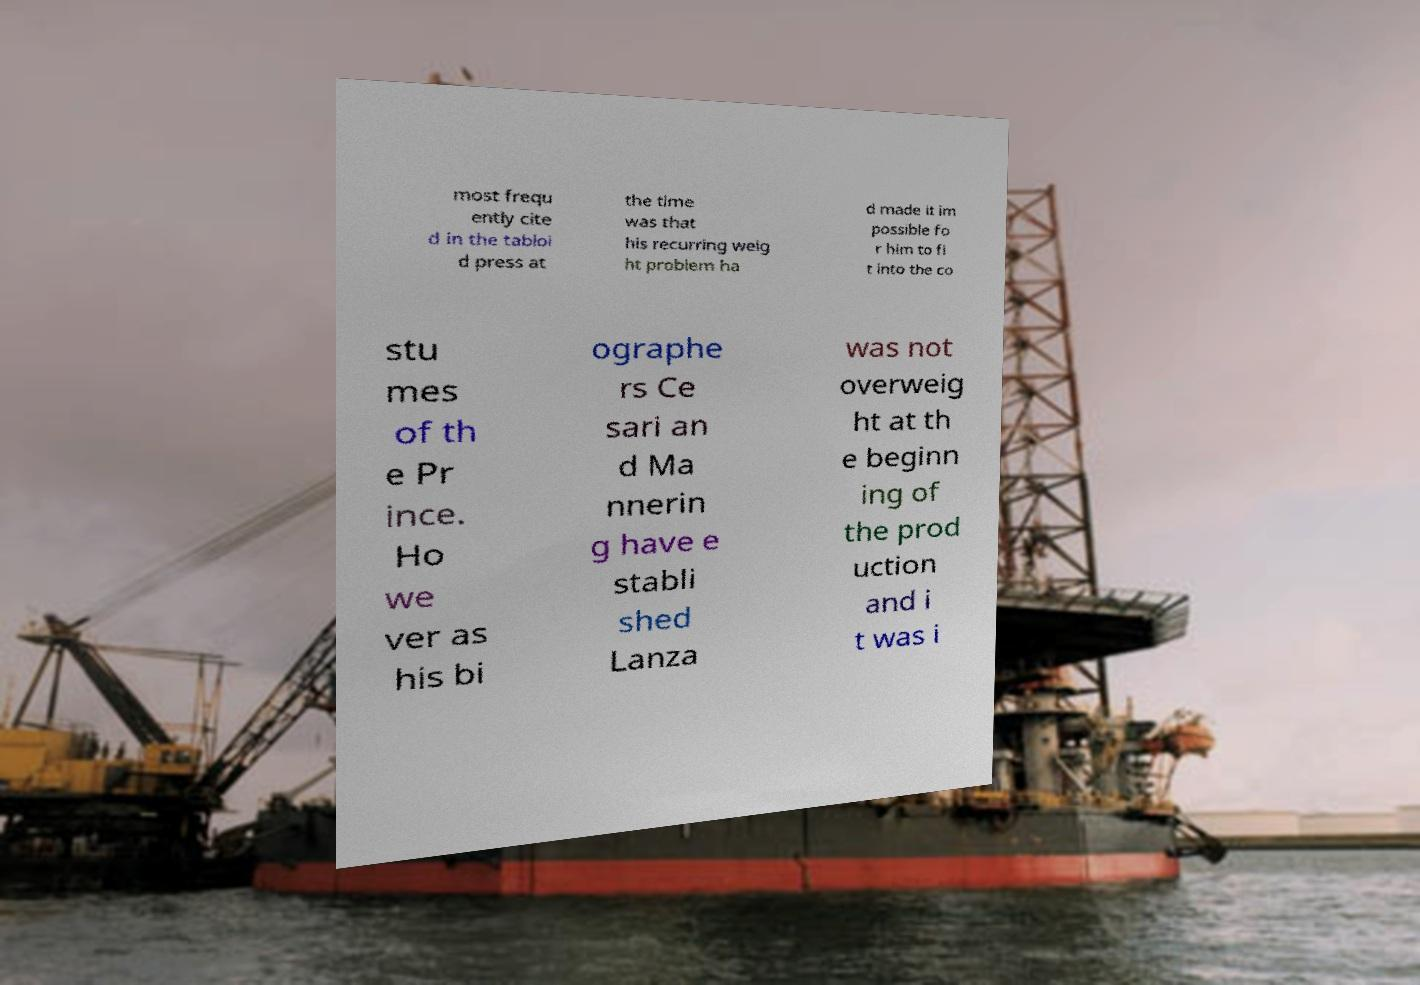Could you extract and type out the text from this image? most frequ ently cite d in the tabloi d press at the time was that his recurring weig ht problem ha d made it im possible fo r him to fi t into the co stu mes of th e Pr ince. Ho we ver as his bi ographe rs Ce sari an d Ma nnerin g have e stabli shed Lanza was not overweig ht at th e beginn ing of the prod uction and i t was i 